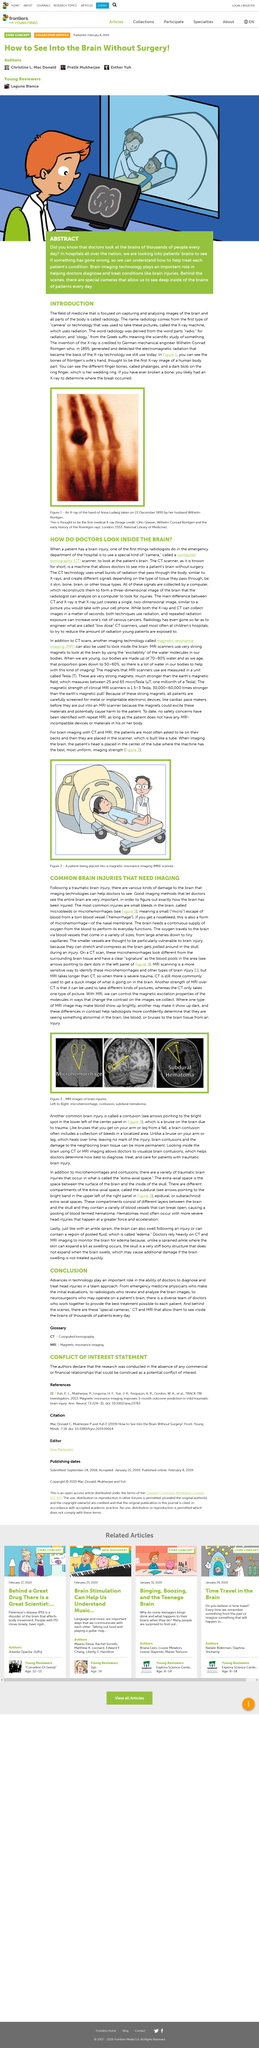Specify some key components in this picture. Brain imaging technologies such as CT scans and MRI are commonly used to visualize the brain and its structures. Figure 3 displays magnetic resonance imaging (MRI) scans of brain injury cases. The name "Radiology" comes from the first type of camera or technology used to take these pictures, known as the x-ray machine, which utilizes radiation. The word "Radiology" is derived from the combination of the word "radio," meaning radiation, and "ology," which is a suffix that denotes the scientific study of a particular subject. Radiology is a medical field that utilizes imaging techniques to capture and analyze images of the brain and other parts of the body for diagnostic and therapeutic purposes. 